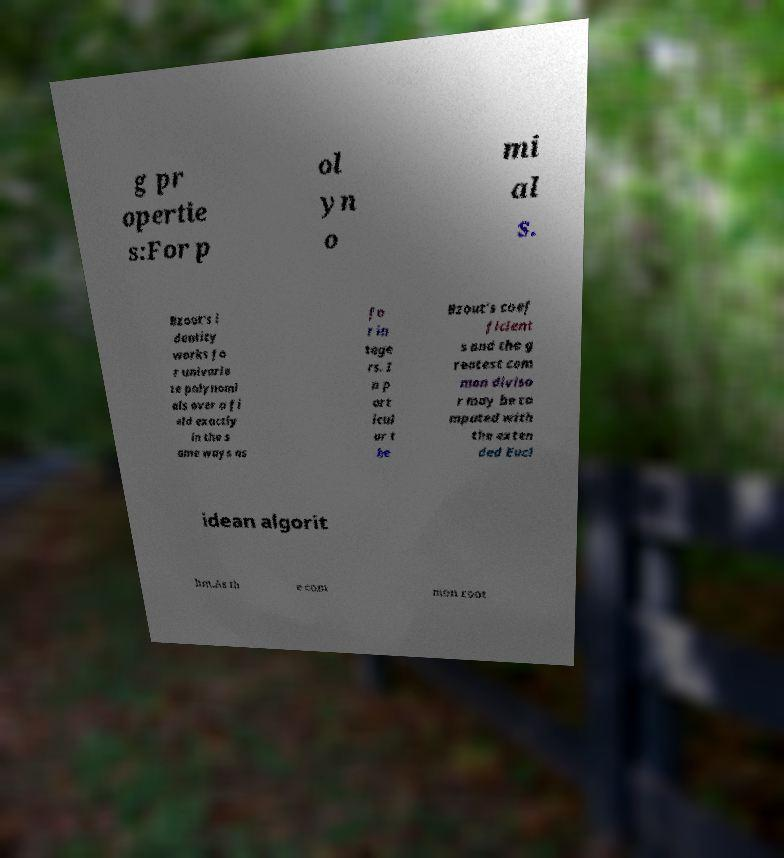Could you assist in decoding the text presented in this image and type it out clearly? g pr opertie s:For p ol yn o mi al s. Bzout's i dentity works fo r univaria te polynomi als over a fi eld exactly in the s ame ways as fo r in tege rs. I n p art icul ar t he Bzout's coef ficient s and the g reatest com mon diviso r may be co mputed with the exten ded Eucl idean algorit hm.As th e com mon root 